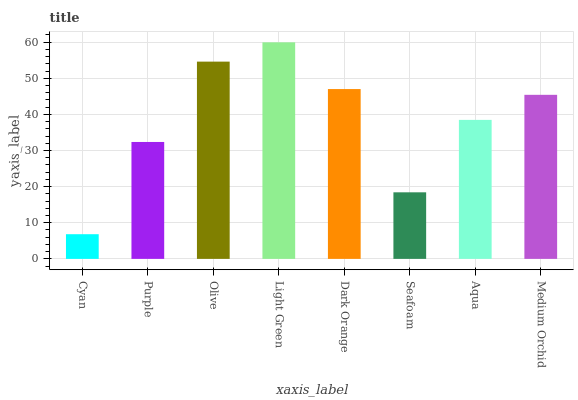Is Purple the minimum?
Answer yes or no. No. Is Purple the maximum?
Answer yes or no. No. Is Purple greater than Cyan?
Answer yes or no. Yes. Is Cyan less than Purple?
Answer yes or no. Yes. Is Cyan greater than Purple?
Answer yes or no. No. Is Purple less than Cyan?
Answer yes or no. No. Is Medium Orchid the high median?
Answer yes or no. Yes. Is Aqua the low median?
Answer yes or no. Yes. Is Aqua the high median?
Answer yes or no. No. Is Cyan the low median?
Answer yes or no. No. 